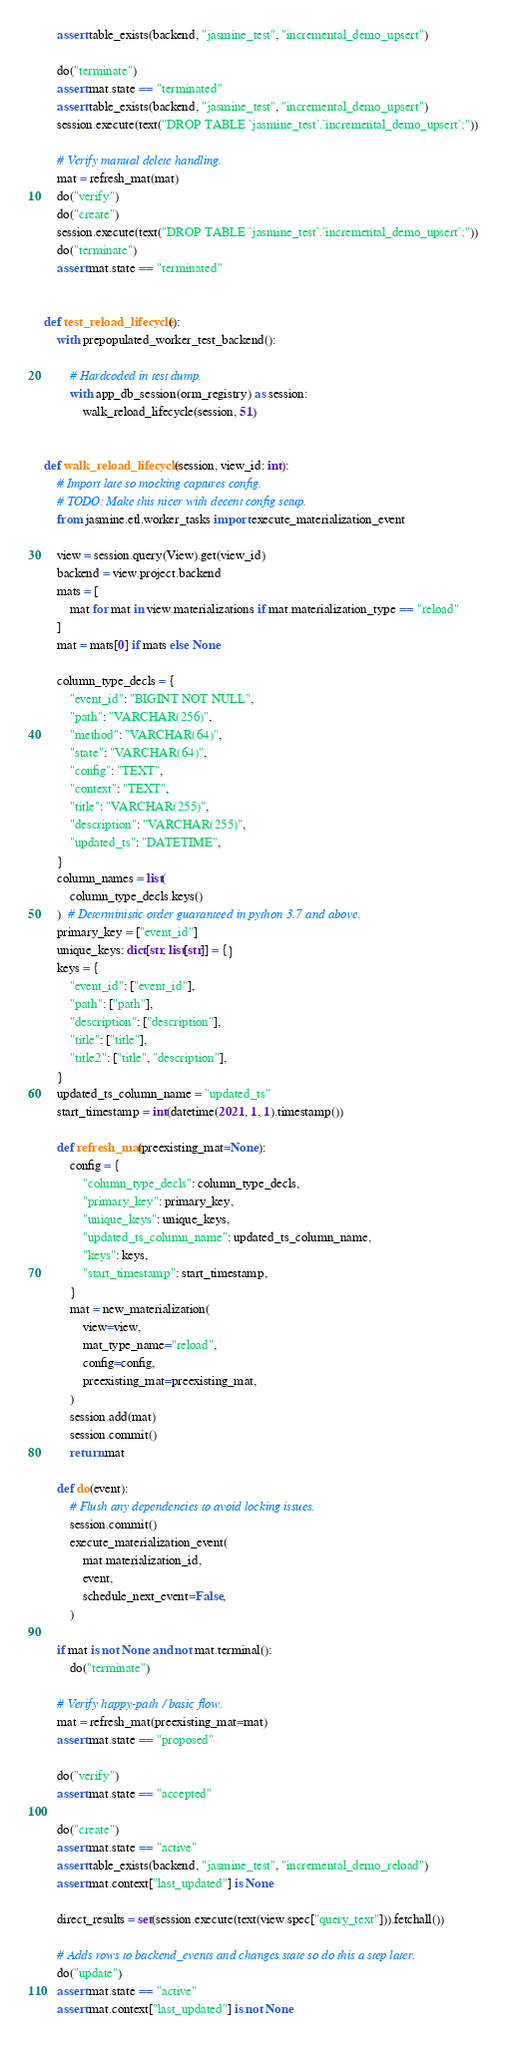<code> <loc_0><loc_0><loc_500><loc_500><_Python_>    assert table_exists(backend, "jasmine_test", "incremental_demo_upsert")

    do("terminate")
    assert mat.state == "terminated"
    assert table_exists(backend, "jasmine_test", "incremental_demo_upsert")
    session.execute(text("DROP TABLE `jasmine_test`.`incremental_demo_upsert`;"))

    # Verify manual delete handling.
    mat = refresh_mat(mat)
    do("verify")
    do("create")
    session.execute(text("DROP TABLE `jasmine_test`.`incremental_demo_upsert`;"))
    do("terminate")
    assert mat.state == "terminated"


def test_reload_lifecycle():
    with prepopulated_worker_test_backend():

        # Hardcoded in test dump.
        with app_db_session(orm_registry) as session:
            walk_reload_lifecycle(session, 51)


def walk_reload_lifecycle(session, view_id: int):
    # Import late so mocking captures config.
    # TODO: Make this nicer with decent config setup.
    from jasmine.etl.worker_tasks import execute_materialization_event

    view = session.query(View).get(view_id)
    backend = view.project.backend
    mats = [
        mat for mat in view.materializations if mat.materialization_type == "reload"
    ]
    mat = mats[0] if mats else None

    column_type_decls = {
        "event_id": "BIGINT NOT NULL",
        "path": "VARCHAR(256)",
        "method": "VARCHAR(64)",
        "state": "VARCHAR(64)",
        "config": "TEXT",
        "context": "TEXT",
        "title": "VARCHAR(255)",
        "description": "VARCHAR(255)",
        "updated_ts": "DATETIME",
    }
    column_names = list(
        column_type_decls.keys()
    )  # Deterministic order guaranteed in python 3.7 and above.
    primary_key = ["event_id"]
    unique_keys: dict[str, list[str]] = {}
    keys = {
        "event_id": ["event_id"],
        "path": ["path"],
        "description": ["description"],
        "title": ["title"],
        "title2": ["title", "description"],
    }
    updated_ts_column_name = "updated_ts"
    start_timestamp = int(datetime(2021, 1, 1).timestamp())

    def refresh_mat(preexisting_mat=None):
        config = {
            "column_type_decls": column_type_decls,
            "primary_key": primary_key,
            "unique_keys": unique_keys,
            "updated_ts_column_name": updated_ts_column_name,
            "keys": keys,
            "start_timestamp": start_timestamp,
        }
        mat = new_materialization(
            view=view,
            mat_type_name="reload",
            config=config,
            preexisting_mat=preexisting_mat,
        )
        session.add(mat)
        session.commit()
        return mat

    def do(event):
        # Flush any dependencies to avoid locking issues.
        session.commit()
        execute_materialization_event(
            mat.materialization_id,
            event,
            schedule_next_event=False,
        )

    if mat is not None and not mat.terminal():
        do("terminate")

    # Verify happy-path / basic flow.
    mat = refresh_mat(preexisting_mat=mat)
    assert mat.state == "proposed"

    do("verify")
    assert mat.state == "accepted"

    do("create")
    assert mat.state == "active"
    assert table_exists(backend, "jasmine_test", "incremental_demo_reload")
    assert mat.context["last_updated"] is None

    direct_results = set(session.execute(text(view.spec["query_text"])).fetchall())

    # Adds rows to backend_events and changes state so do this a step later.
    do("update")
    assert mat.state == "active"
    assert mat.context["last_updated"] is not None</code> 